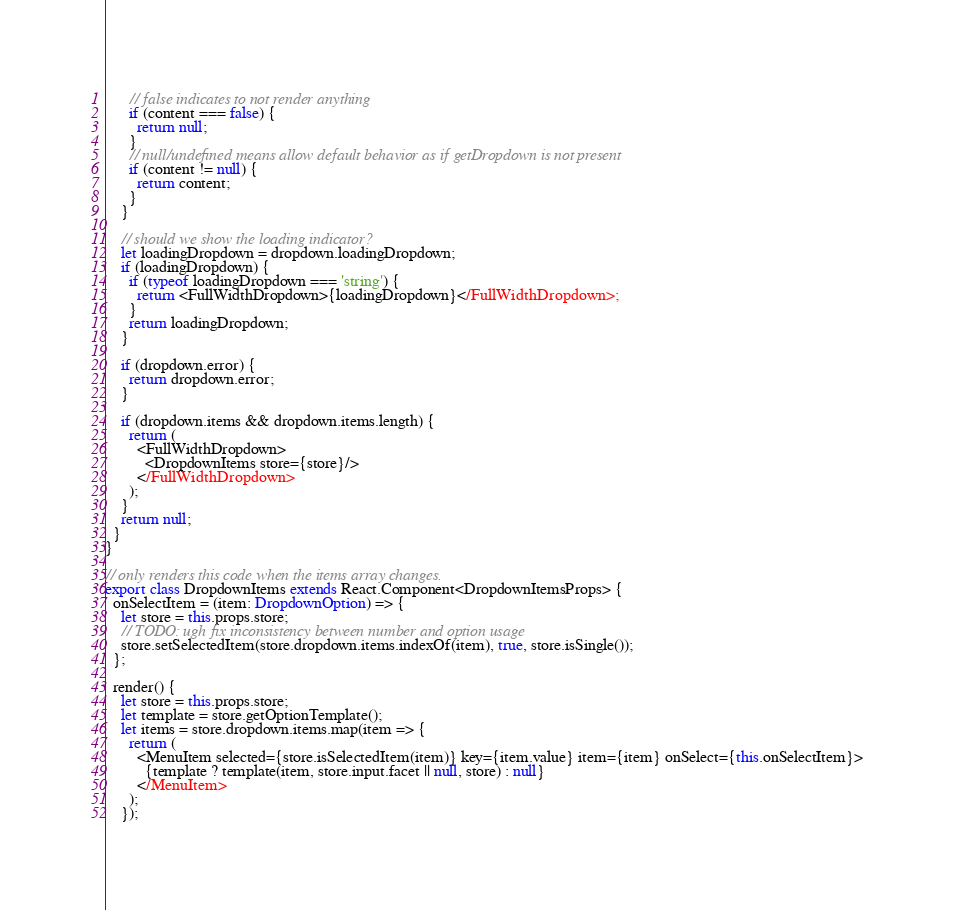Convert code to text. <code><loc_0><loc_0><loc_500><loc_500><_TypeScript_>      // false indicates to not render anything
      if (content === false) {
        return null;
      }
      // null/undefined means allow default behavior as if getDropdown is not present
      if (content != null) {
        return content;
      }
    }

    // should we show the loading indicator?
    let loadingDropdown = dropdown.loadingDropdown;
    if (loadingDropdown) {
      if (typeof loadingDropdown === 'string') {
        return <FullWidthDropdown>{loadingDropdown}</FullWidthDropdown>;
      }
      return loadingDropdown;
    }

    if (dropdown.error) {
      return dropdown.error;
    }

    if (dropdown.items && dropdown.items.length) {
      return (
        <FullWidthDropdown>
          <DropdownItems store={store}/>
        </FullWidthDropdown>
      );
    }
    return null;
  }
}

// only renders this code when the items array changes.
export class DropdownItems extends React.Component<DropdownItemsProps> {
  onSelectItem = (item: DropdownOption) => {
    let store = this.props.store;
    // TODO: ugh fix inconsistency between number and option usage
    store.setSelectedItem(store.dropdown.items.indexOf(item), true, store.isSingle());
  };

  render() {
    let store = this.props.store;
    let template = store.getOptionTemplate();
    let items = store.dropdown.items.map(item => {
      return (
        <MenuItem selected={store.isSelectedItem(item)} key={item.value} item={item} onSelect={this.onSelectItem}>
          {template ? template(item, store.input.facet || null, store) : null}
        </MenuItem>
      );
    });
</code> 